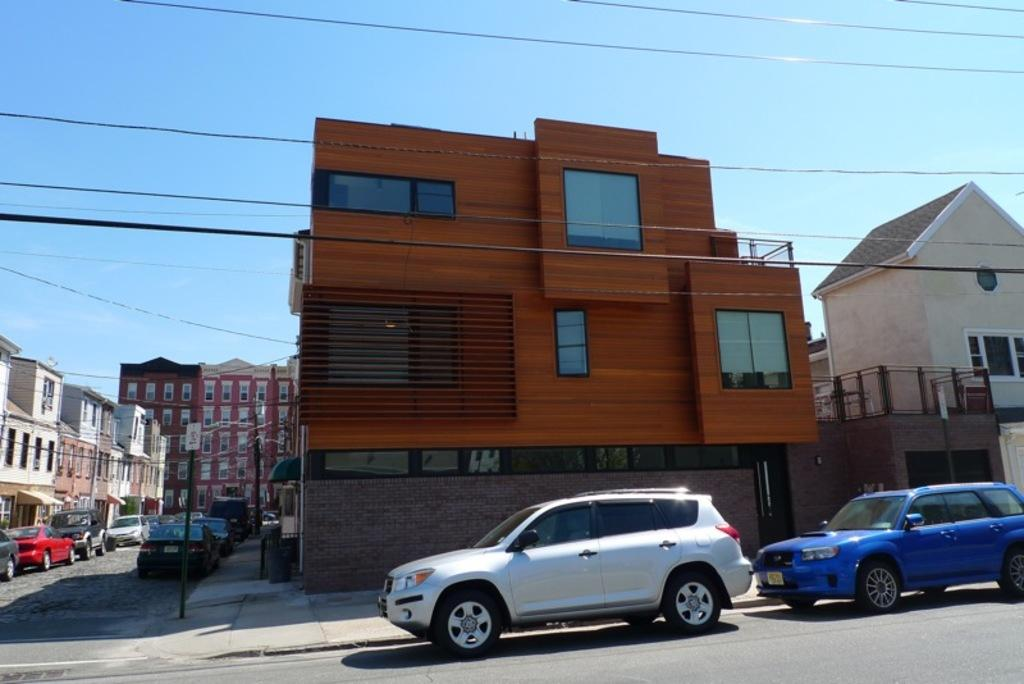What type of vehicles can be seen on the road in the image? There are cars on the road in the image. What structures are visible in the image? There are buildings in the image. What objects are present in the image that are related to infrastructure? There are poles and wires in the image. What part of the natural environment is visible in the image? The sky is visible in the background of the image. What letter can be seen on the cars in the image? There is no specific letter mentioned on the cars in the image. Can you hear the sound of the cars in the image? The image is a still picture, so it does not contain any sound. 